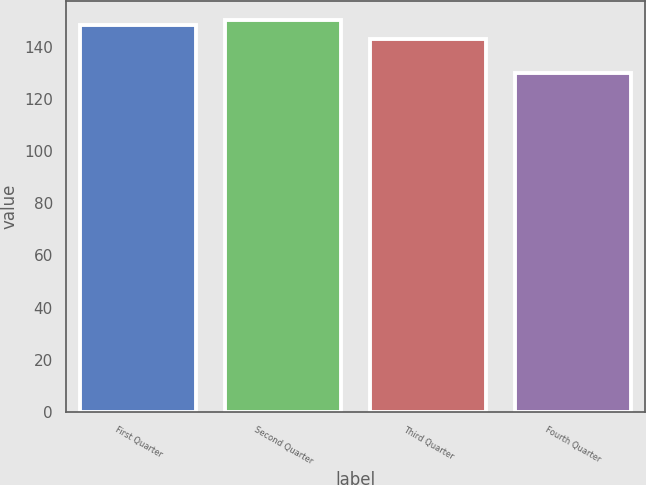Convert chart. <chart><loc_0><loc_0><loc_500><loc_500><bar_chart><fcel>First Quarter<fcel>Second Quarter<fcel>Third Quarter<fcel>Fourth Quarter<nl><fcel>148.34<fcel>150.29<fcel>142.92<fcel>130<nl></chart> 